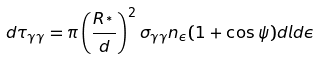Convert formula to latex. <formula><loc_0><loc_0><loc_500><loc_500>d \tau _ { \gamma \gamma } = \pi \left ( \frac { R _ { ^ { * } } } { d } \right ) ^ { 2 } \sigma _ { \gamma \gamma } n _ { \epsilon } ( 1 + \cos \psi ) d l d \epsilon</formula> 